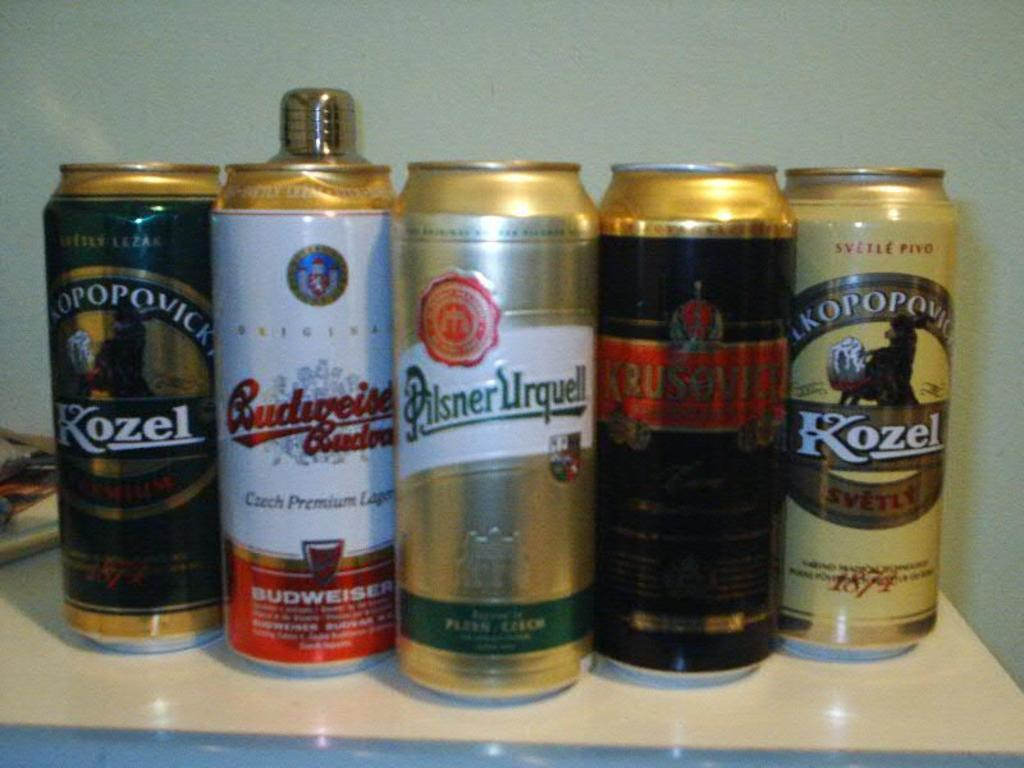<image>
Write a terse but informative summary of the picture. Five different beer cans are all lined up, including two Kozel cans. 